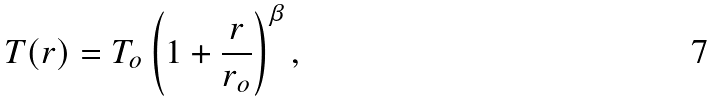Convert formula to latex. <formula><loc_0><loc_0><loc_500><loc_500>T ( r ) = T _ { o } \left ( 1 + \frac { r } { r _ { o } } \right ) ^ { \beta } ,</formula> 